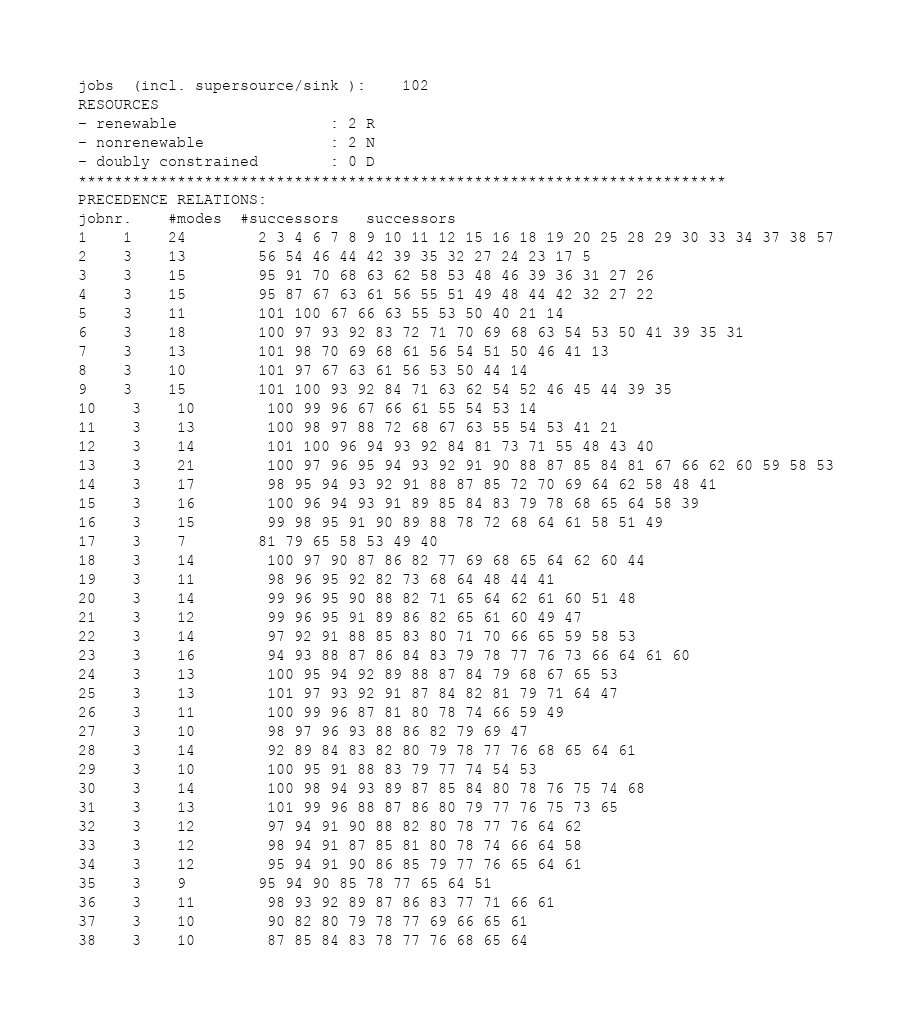<code> <loc_0><loc_0><loc_500><loc_500><_ObjectiveC_>jobs  (incl. supersource/sink ):	102
RESOURCES
- renewable                 : 2 R
- nonrenewable              : 2 N
- doubly constrained        : 0 D
************************************************************************
PRECEDENCE RELATIONS:
jobnr.    #modes  #successors   successors
1	1	24		2 3 4 6 7 8 9 10 11 12 15 16 18 19 20 25 28 29 30 33 34 37 38 57 
2	3	13		56 54 46 44 42 39 35 32 27 24 23 17 5 
3	3	15		95 91 70 68 63 62 58 53 48 46 39 36 31 27 26 
4	3	15		95 87 67 63 61 56 55 51 49 48 44 42 32 27 22 
5	3	11		101 100 67 66 63 55 53 50 40 21 14 
6	3	18		100 97 93 92 83 72 71 70 69 68 63 54 53 50 41 39 35 31 
7	3	13		101 98 70 69 68 61 56 54 51 50 46 41 13 
8	3	10		101 97 67 63 61 56 53 50 44 14 
9	3	15		101 100 93 92 84 71 63 62 54 52 46 45 44 39 35 
10	3	10		100 99 96 67 66 61 55 54 53 14 
11	3	13		100 98 97 88 72 68 67 63 55 54 53 41 21 
12	3	14		101 100 96 94 93 92 84 81 73 71 55 48 43 40 
13	3	21		100 97 96 95 94 93 92 91 90 88 87 85 84 81 67 66 62 60 59 58 53 
14	3	17		98 95 94 93 92 91 88 87 85 72 70 69 64 62 58 48 41 
15	3	16		100 96 94 93 91 89 85 84 83 79 78 68 65 64 58 39 
16	3	15		99 98 95 91 90 89 88 78 72 68 64 61 58 51 49 
17	3	7		81 79 65 58 53 49 40 
18	3	14		100 97 90 87 86 82 77 69 68 65 64 62 60 44 
19	3	11		98 96 95 92 82 73 68 64 48 44 41 
20	3	14		99 96 95 90 88 82 71 65 64 62 61 60 51 48 
21	3	12		99 96 95 91 89 86 82 65 61 60 49 47 
22	3	14		97 92 91 88 85 83 80 71 70 66 65 59 58 53 
23	3	16		94 93 88 87 86 84 83 79 78 77 76 73 66 64 61 60 
24	3	13		100 95 94 92 89 88 87 84 79 68 67 65 53 
25	3	13		101 97 93 92 91 87 84 82 81 79 71 64 47 
26	3	11		100 99 96 87 81 80 78 74 66 59 49 
27	3	10		98 97 96 93 88 86 82 79 69 47 
28	3	14		92 89 84 83 82 80 79 78 77 76 68 65 64 61 
29	3	10		100 95 91 88 83 79 77 74 54 53 
30	3	14		100 98 94 93 89 87 85 84 80 78 76 75 74 68 
31	3	13		101 99 96 88 87 86 80 79 77 76 75 73 65 
32	3	12		97 94 91 90 88 82 80 78 77 76 64 62 
33	3	12		98 94 91 87 85 81 80 78 74 66 64 58 
34	3	12		95 94 91 90 86 85 79 77 76 65 64 61 
35	3	9		95 94 90 85 78 77 65 64 51 
36	3	11		98 93 92 89 87 86 83 77 71 66 61 
37	3	10		90 82 80 79 78 77 69 66 65 61 
38	3	10		87 85 84 83 78 77 76 68 65 64 </code> 